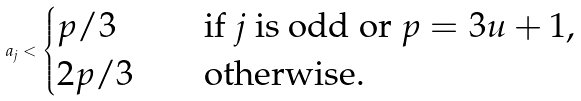Convert formula to latex. <formula><loc_0><loc_0><loc_500><loc_500>a _ { j } < \begin{cases} p / 3 \quad & \text {if $j$ is odd or $p = 3u+1$,} \\ 2 p / 3 \quad & \text {otherwise.} \end{cases}</formula> 